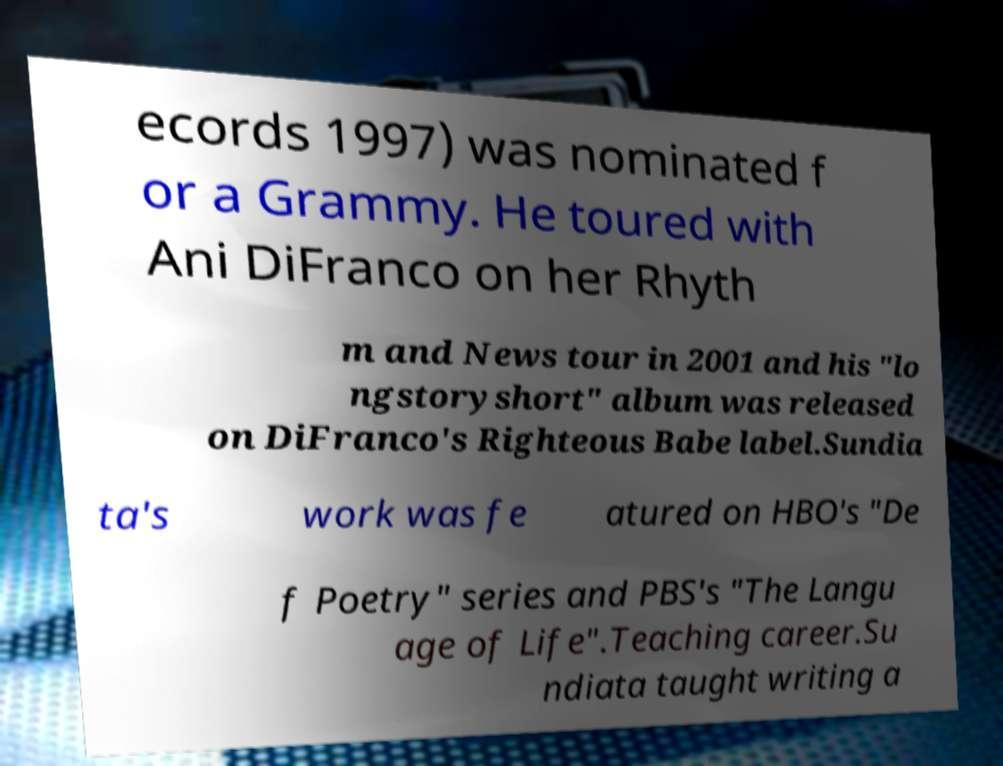Please read and relay the text visible in this image. What does it say? ecords 1997) was nominated f or a Grammy. He toured with Ani DiFranco on her Rhyth m and News tour in 2001 and his "lo ngstoryshort" album was released on DiFranco's Righteous Babe label.Sundia ta's work was fe atured on HBO's "De f Poetry" series and PBS's "The Langu age of Life".Teaching career.Su ndiata taught writing a 